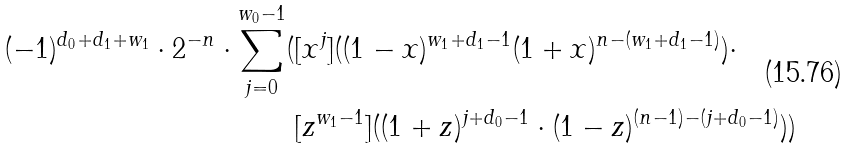<formula> <loc_0><loc_0><loc_500><loc_500>( - 1 ) ^ { d _ { 0 } + d _ { 1 } + w _ { 1 } } \cdot 2 ^ { - n } \cdot \sum _ { j = 0 } ^ { w _ { 0 } - 1 } ( & [ x ^ { j } ] ( ( 1 - x ) ^ { w _ { 1 } + d _ { 1 } - 1 } ( 1 + x ) ^ { n - ( w _ { 1 } + d _ { 1 } - 1 ) } ) \cdot \\ & [ z ^ { w _ { 1 } - 1 } ] ( ( 1 + z ) ^ { j + d _ { 0 } - 1 } \cdot ( 1 - z ) ^ { ( n - 1 ) - ( j + d _ { 0 } - 1 ) } ) )</formula> 